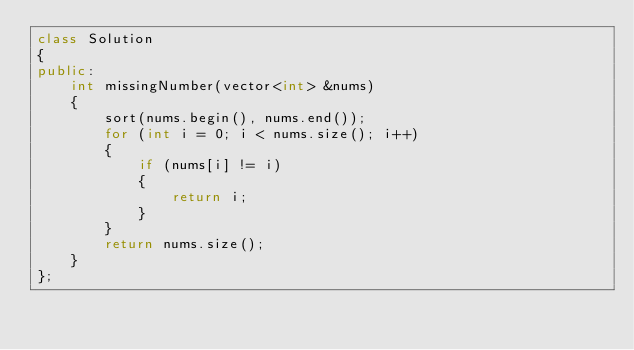Convert code to text. <code><loc_0><loc_0><loc_500><loc_500><_C++_>class Solution
{
public:
    int missingNumber(vector<int> &nums)
    {
        sort(nums.begin(), nums.end());
        for (int i = 0; i < nums.size(); i++)
        {
            if (nums[i] != i)
            {
                return i;
            }
        }
        return nums.size();
    }
};</code> 